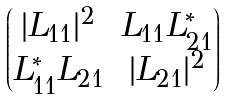<formula> <loc_0><loc_0><loc_500><loc_500>\begin{pmatrix} | L _ { 1 1 } | ^ { 2 } & L _ { 1 1 } L _ { 2 1 } ^ { * } \\ L ^ { * } _ { 1 1 } L _ { 2 1 } & | L _ { 2 1 } | ^ { 2 } \end{pmatrix}</formula> 